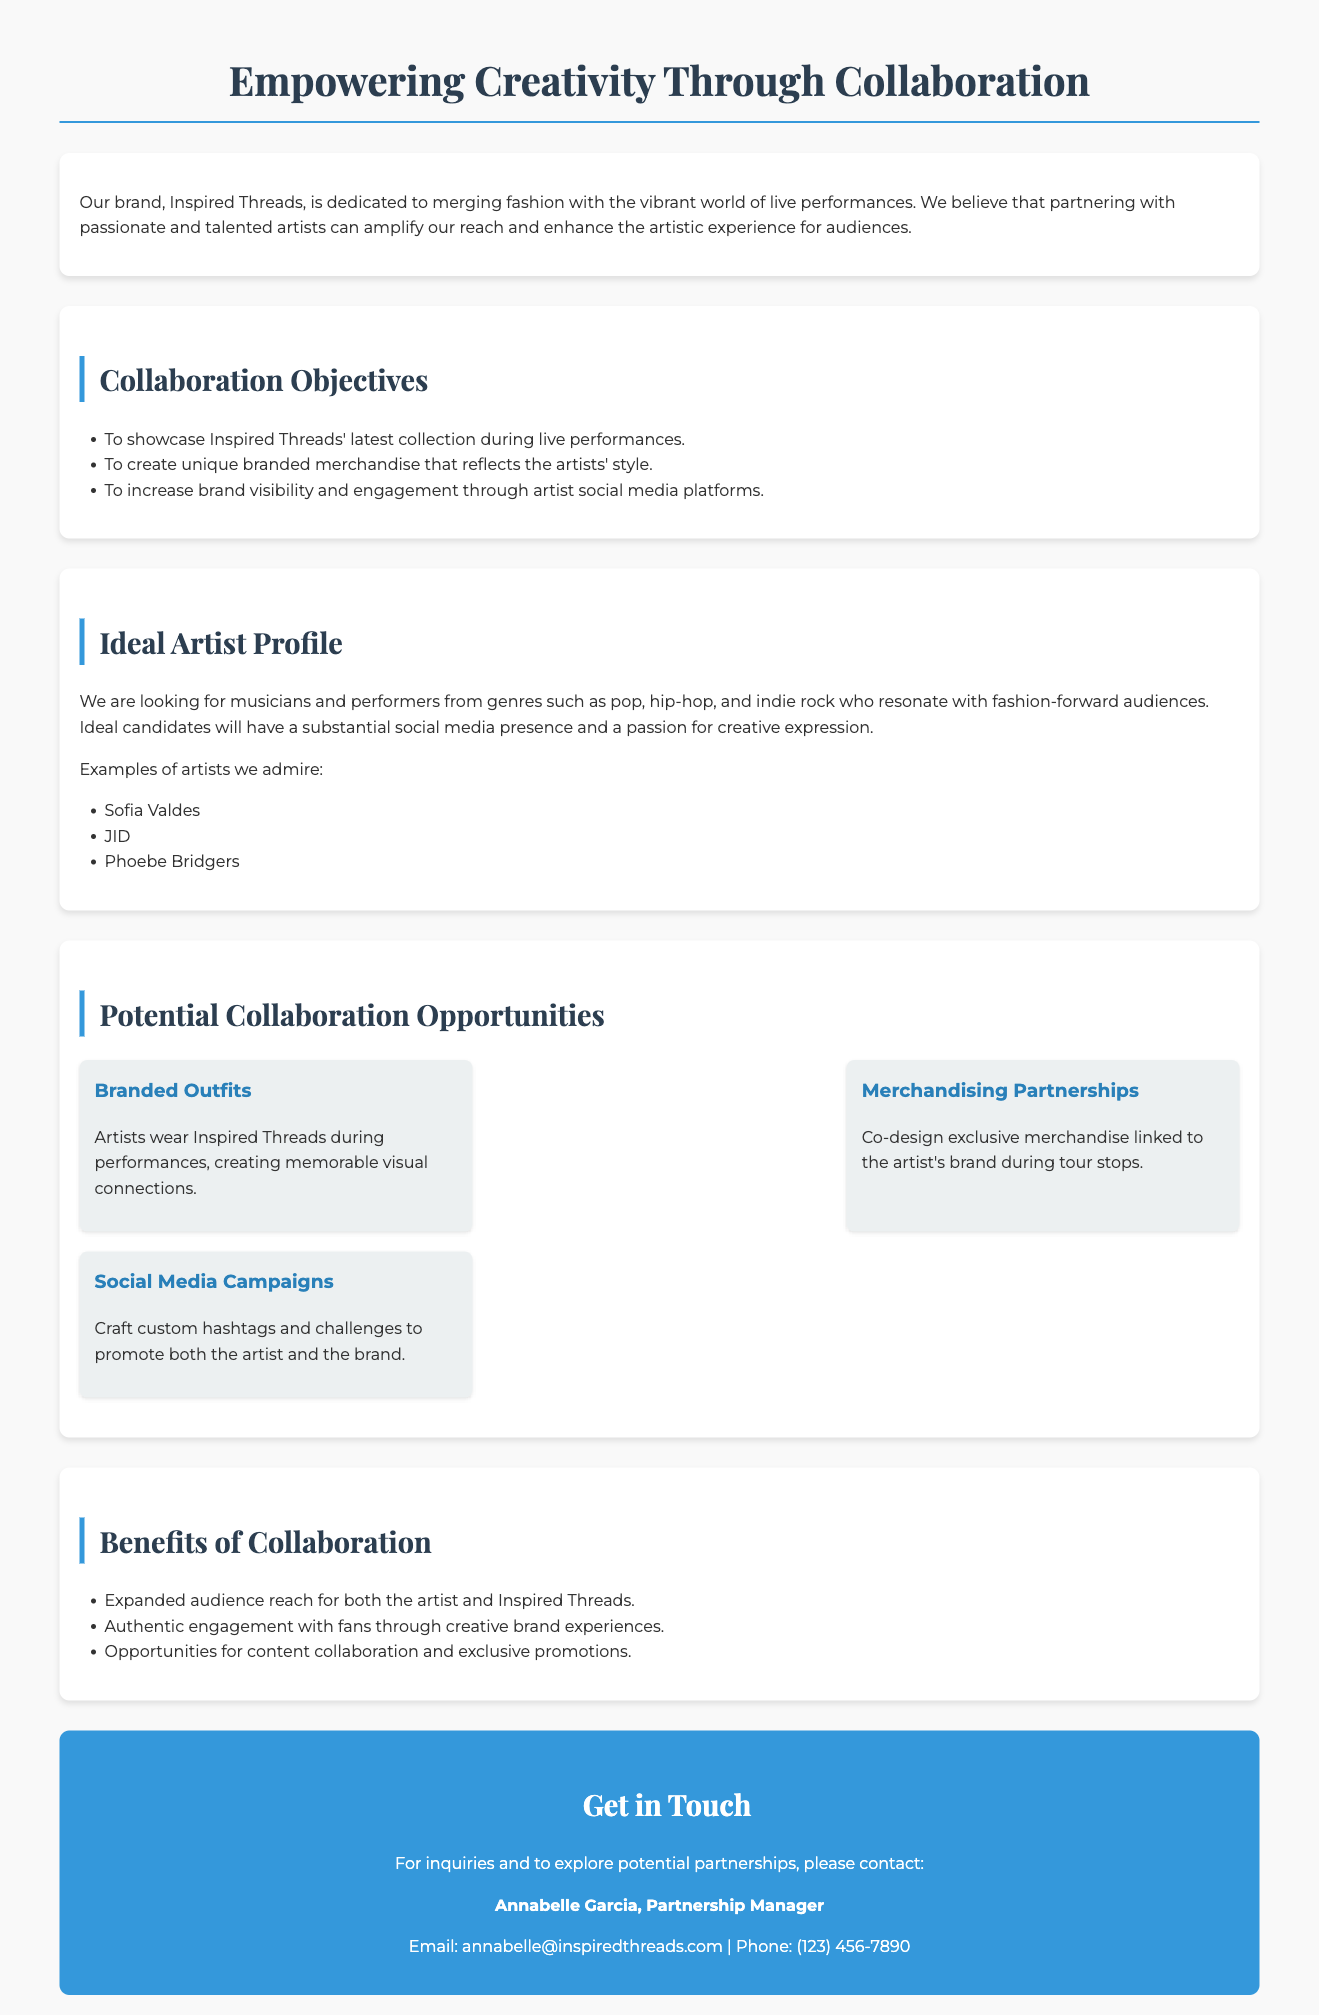What is the name of the brand? The brand name is mentioned at the beginning of the document as "Inspired Threads."
Answer: Inspired Threads Who is the Partnership Manager? The document explicitly states the name of the Partnership Manager for inquiries.
Answer: Annabelle Garcia Which social media platforms are specifically mentioned for engagement? The document discusses the use of artist social media platforms for increasing brand visibility.
Answer: Artist social media platforms What type of artists are sought for collaboration? The document describes the ideal artist profile that includes musicians and performers from specific genres.
Answer: Pop, hip-hop, and indie rock What is one of the collaboration objectives? The document lists objectives such as showcasing the latest collection during performances.
Answer: To showcase Inspired Threads' latest collection during live performances How many collaboration opportunities are listed? The document provides a section detailing potential collaboration opportunities.
Answer: Three What is an example of a branded collaboration option? The document gives specific examples of collaboration options that include branded outfits.
Answer: Branded Outfits What is the email contact for partnership inquiries? The document provides contact information, including an email address for partnership inquiries.
Answer: annabelle@inspiredthreads.com What is the anticipated benefit of collaboration mentioned? The document outlines several benefits of collaboration between artists and the brand.
Answer: Expanded audience reach for both the artist and Inspired Threads 